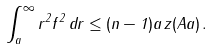Convert formula to latex. <formula><loc_0><loc_0><loc_500><loc_500>\int _ { a } ^ { \infty } r ^ { 2 } f ^ { 2 } \, d r \leq ( n - 1 ) a \, z ( A a ) \, .</formula> 